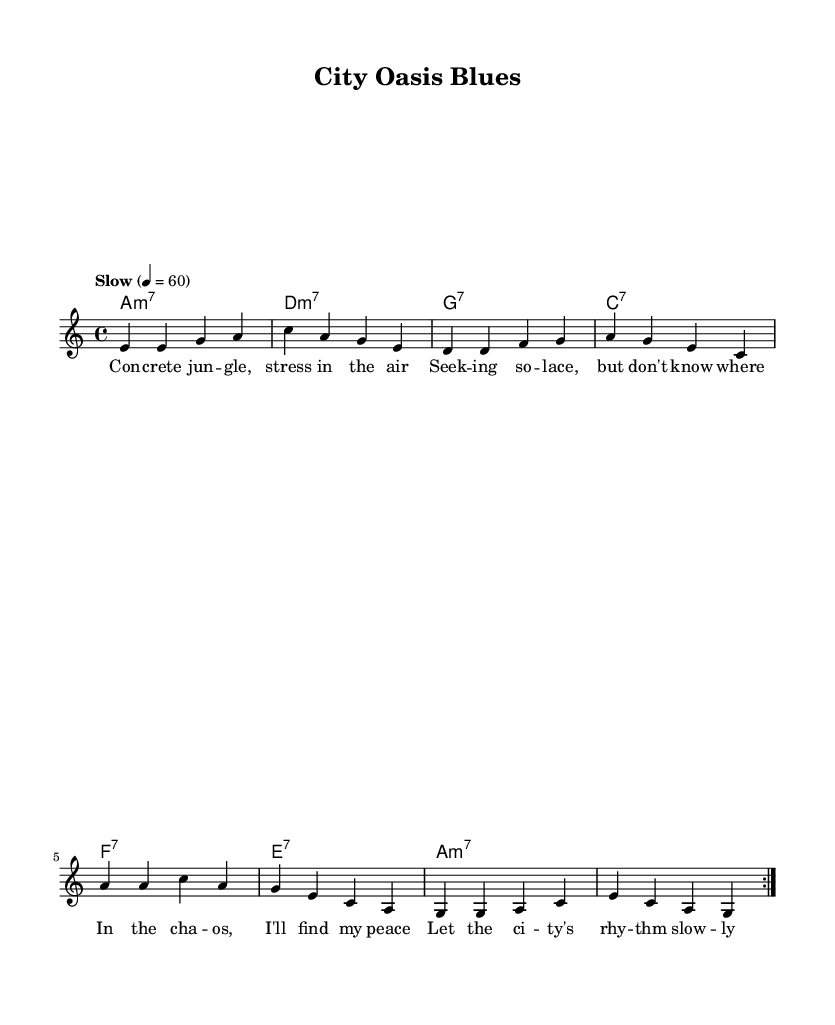What is the key signature of this music? The key signature is A minor, which has no sharps or flats. You can identify the key signature by looking at the clef at the beginning of the staff, where it indicates the key with the absence of sharps or flats.
Answer: A minor What is the time signature of this music? The time signature is 4/4, which means there are four beats in each measure, and the quarter note gets one beat. You can find this information at the beginning of the staff, right after the key signature.
Answer: 4/4 What is the tempo marking for this piece? The tempo marking is "Slow" with a metronome marking of 60 BPM, indicating a slow-paced rhythm for the performance. This is often located above the staff at the beginning of the music.
Answer: Slow How many measures are there in the repeated section? There are eight measures in the repeated section of the melody. You can determine this by counting the measures within the "repeat volta" directive at the start and end of the melody.
Answer: Eight What is the first chord in the harmonies? The first chord in the harmonies is A minor seventh (A:m7). You can identify this by looking at the chord names written below the staff, starting from the leftmost side.
Answer: A minor seventh What lyrical theme is explored in this piece? The lyrical theme explores finding peace amidst chaos in the city. The lyrics describe the search for solace against the backdrop of urban stress and noise, reflecting a personal journey toward tranquility.
Answer: Finding peace amidst chaos What type of music is this composition classified as? This composition is classified as Blues, characterized by the typical chord progressions and themes centered around emotional expression and life experiences. You can identify this from the blues structure and lyrical content, which aligns with the genre.
Answer: Blues 